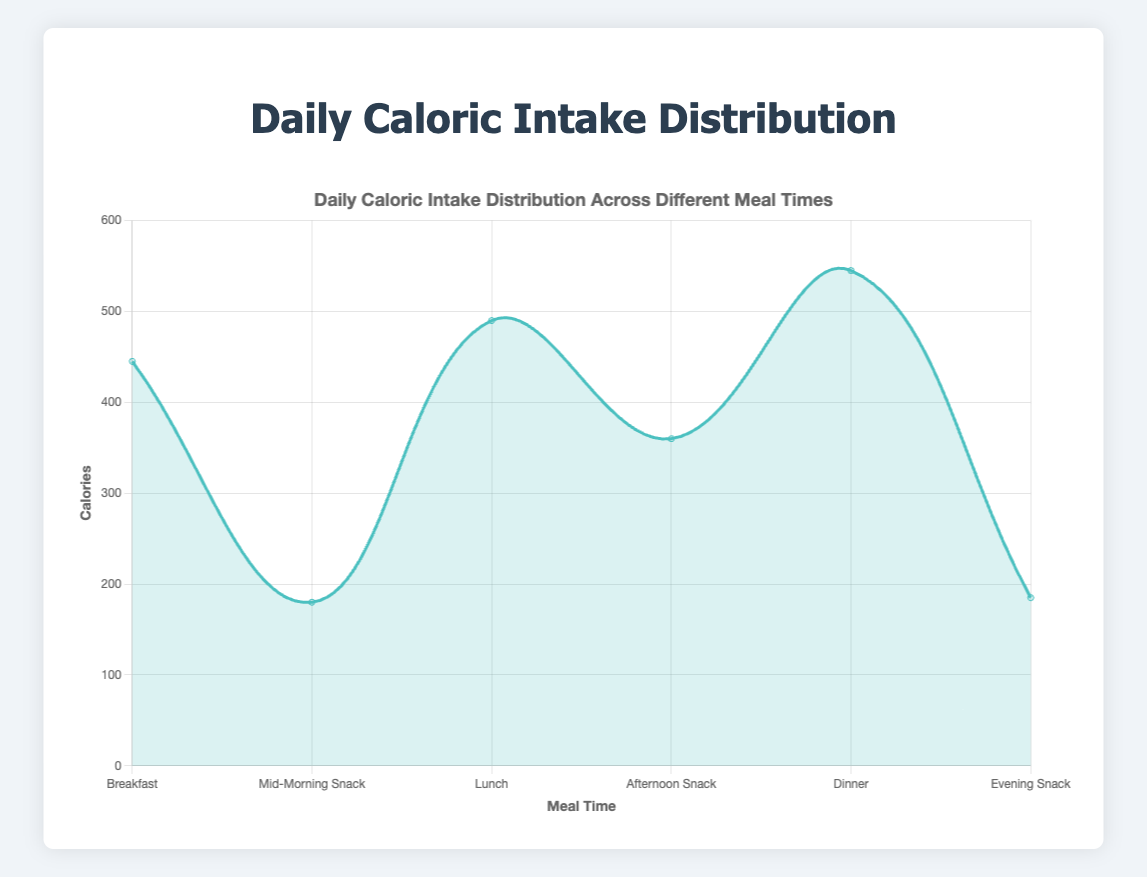What is the title of the figure? The title is clearly displayed at the top of the figure as part of the standard elements of the chart.
Answer: Daily Caloric Intake Distribution Across Different Meal Times How many meal times are shown in the figure? The figure has meal times labeled on the x-axis, and by counting each label, we find that there are six meal times.
Answer: Six Which meal time has the highest caloric intake? By observing the peak values of the area chart, the highest point corresponds to the dinner time slot.
Answer: Dinner Which meal time has the lowest caloric intake? By examining the troughs in the area chart, the lowest point corresponds to the mid-morning snack slot.
Answer: Mid-Morning Snack How many calories are consumed during lunch? The area chart shows the caloric intake for lunch directly on one of its peaks.
Answer: 490 What is the difference in caloric intake between lunch and dinner? The caloric intake for lunch is 490, and for dinner, it is 545. Subtracting lunch from dinner: 545 - 490 = 55.
Answer: 55 How does the caloric intake at breakfast compare to that at the mid-morning snack? Breakfast has a caloric intake of 445, while the mid-morning snack has 180. Breakfast's intake is significantly higher.
Answer: Breakfast is higher What is the total caloric intake from snacks (mid-morning, afternoon, and evening)? Adding the caloric intakes for mid-morning snack (180), afternoon snack (360), and evening snack (185): 180 + 360 + 185 = 725.
Answer: 725 Which meal time contributes the smallest increment in caloric intake after lunch? After lunch, the next few meal times are afternoon snack, dinner, and evening snack. By calculating the differences, the smallest increment in caloric intake is from lunch (490) to afternoon snack (360), resulting in a decrease.
Answer: Afternoon Snack What percentage of the total daily caloric intake is consumed during dinner? The total caloric intake is the sum of all meal times: 445 + 180 + 490 + 360 + 545 + 185 = 2205. The percentage is (545 / 2205) * 100 ≈ 24.7%.
Answer: 24.7% 